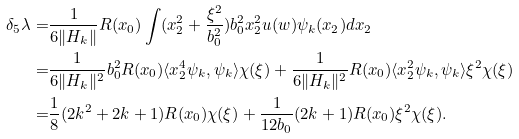Convert formula to latex. <formula><loc_0><loc_0><loc_500><loc_500>\delta _ { 5 } \lambda = & \frac { 1 } { 6 \| H _ { k } \| } R ( x _ { 0 } ) \int ( x ^ { 2 } _ { 2 } + \frac { \xi ^ { 2 } } { b ^ { 2 } _ { 0 } } ) b _ { 0 } ^ { 2 } x _ { 2 } ^ { 2 } u ( w ) \psi _ { k } ( x _ { 2 } ) d x _ { 2 } \\ = & \frac { 1 } { 6 \| H _ { k } \| ^ { 2 } } b _ { 0 } ^ { 2 } R ( x _ { 0 } ) \langle x ^ { 4 } _ { 2 } \psi _ { k } , \psi _ { k } \rangle \chi ( \xi ) + \frac { 1 } { 6 \| H _ { k } \| ^ { 2 } } R ( x _ { 0 } ) \langle x _ { 2 } ^ { 2 } \psi _ { k } , \psi _ { k } \rangle \xi ^ { 2 } \chi ( \xi ) \\ = & \frac { 1 } { 8 } ( 2 k ^ { 2 } + 2 k + 1 ) R ( x _ { 0 } ) \chi ( \xi ) + \frac { 1 } { 1 2 b _ { 0 } } ( 2 k + 1 ) R ( x _ { 0 } ) \xi ^ { 2 } \chi ( \xi ) .</formula> 